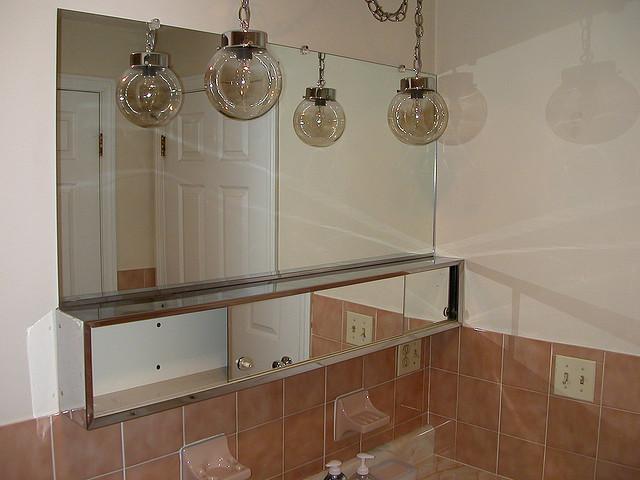What color is the tile?
Give a very brief answer. Brown. Are the lights turned on?
Be succinct. No. Why are there two soap holders?
Concise answer only. 2 people. 